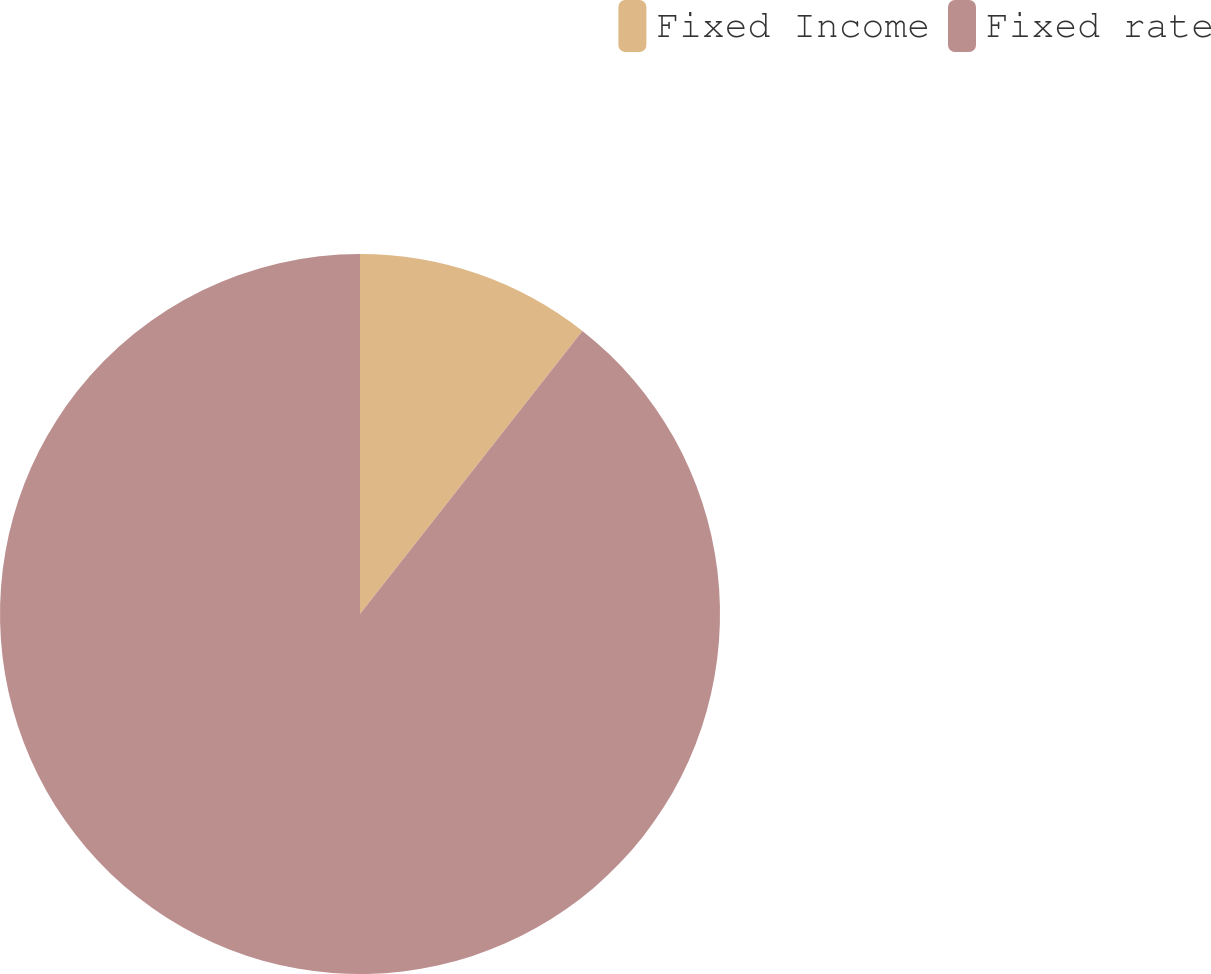Convert chart. <chart><loc_0><loc_0><loc_500><loc_500><pie_chart><fcel>Fixed Income<fcel>Fixed rate<nl><fcel>10.6%<fcel>89.4%<nl></chart> 